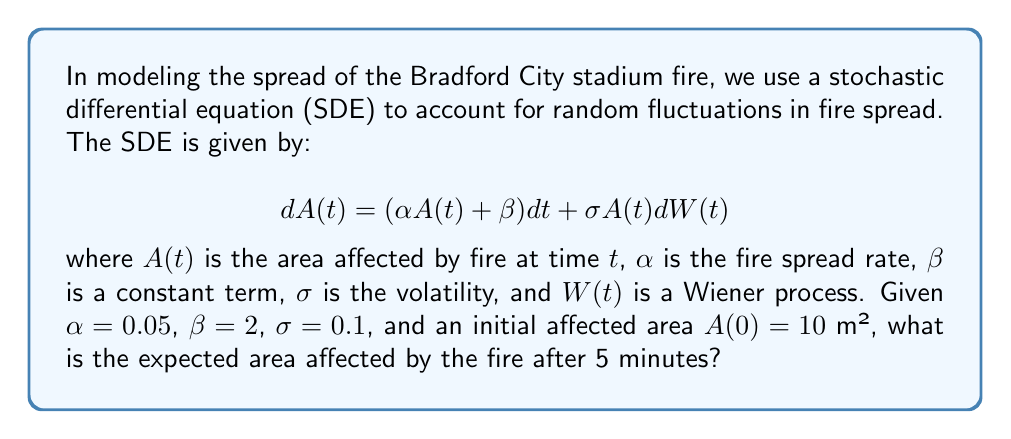Provide a solution to this math problem. To solve this problem, we need to use the properties of SDEs and Itô calculus. The steps are as follows:

1) For an SDE of the form $dX(t) = a(X,t)dt + b(X,t)dW(t)$, the expected value of $X(t)$ is given by:

   $$E[X(t)] = X(0) + \int_0^t E[a(X(s),s)]ds$$

2) In our case, $a(A,t) = \alpha A(t) + \beta$ and $b(A,t) = \sigma A(t)$

3) Let $m(t) = E[A(t)]$. Then we have:

   $$m(t) = A(0) + \int_0^t (\alpha m(s) + \beta)ds$$

4) Differentiating both sides with respect to $t$:

   $$\frac{dm(t)}{dt} = \alpha m(t) + \beta$$

5) This is a first-order linear differential equation. The solution is:

   $$m(t) = (A(0) + \frac{\beta}{\alpha})e^{\alpha t} - \frac{\beta}{\alpha}$$

6) Substituting the given values: $A(0) = 10$, $\alpha = 0.05$, $\beta = 2$, $t = 5$:

   $$m(5) = (10 + \frac{2}{0.05})e^{0.05 \cdot 5} - \frac{2}{0.05}$$

7) Simplifying:

   $$m(5) = 50e^{0.25} - 40 \approx 64.02$$

Therefore, the expected area affected by the fire after 5 minutes is approximately 64.02 m².
Answer: 64.02 m² 